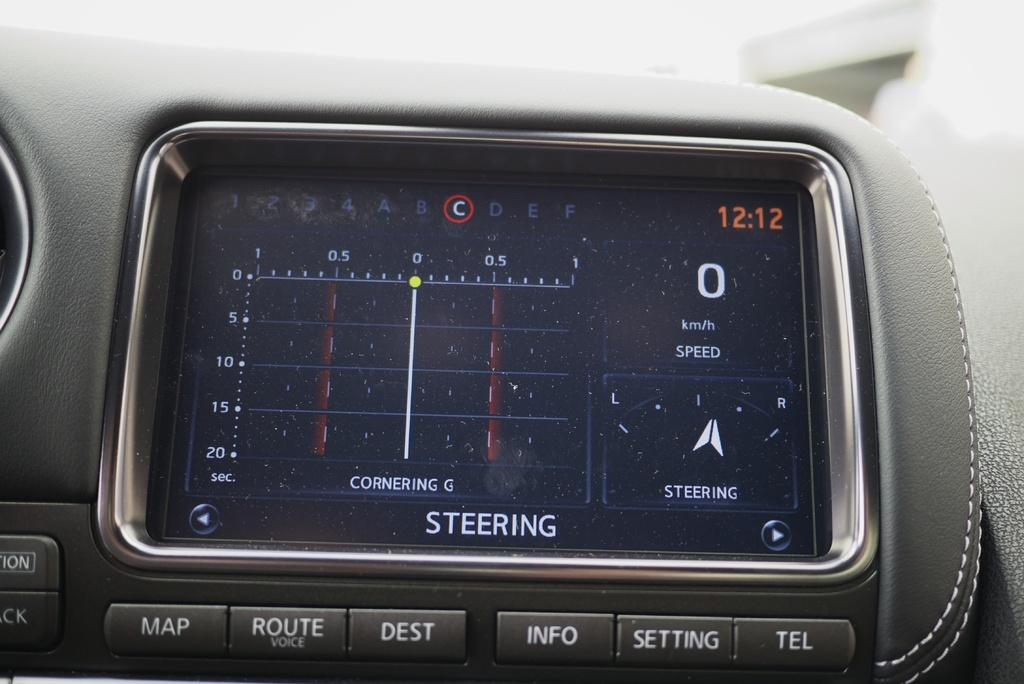<image>
Present a compact description of the photo's key features. the time of 12:12 shown on the car GPS 